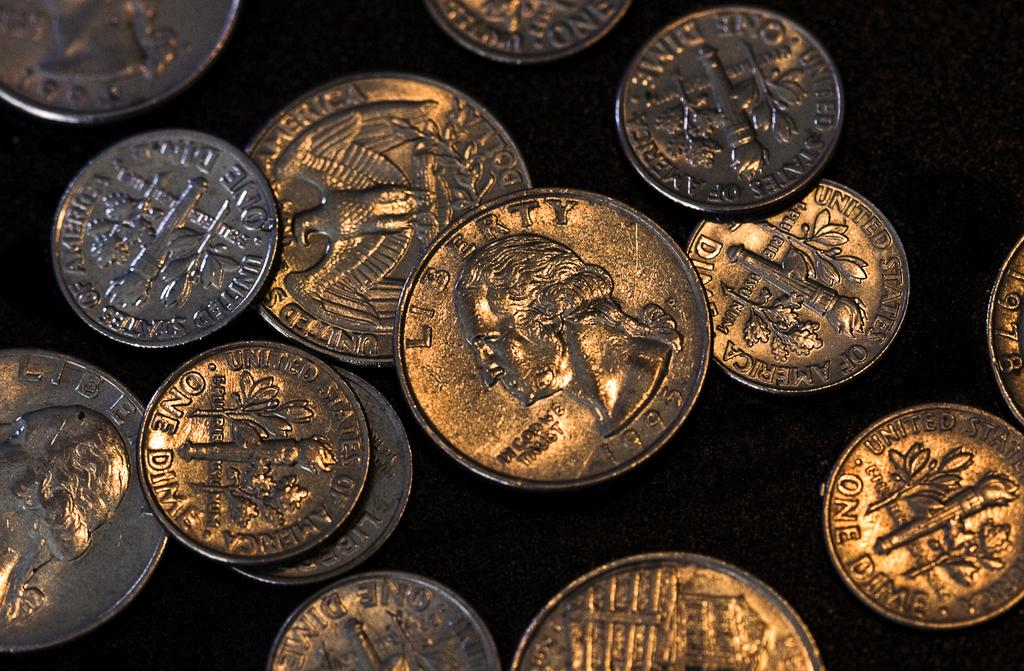<image>
Relay a brief, clear account of the picture shown. American quarters and dimes are on a black background. 